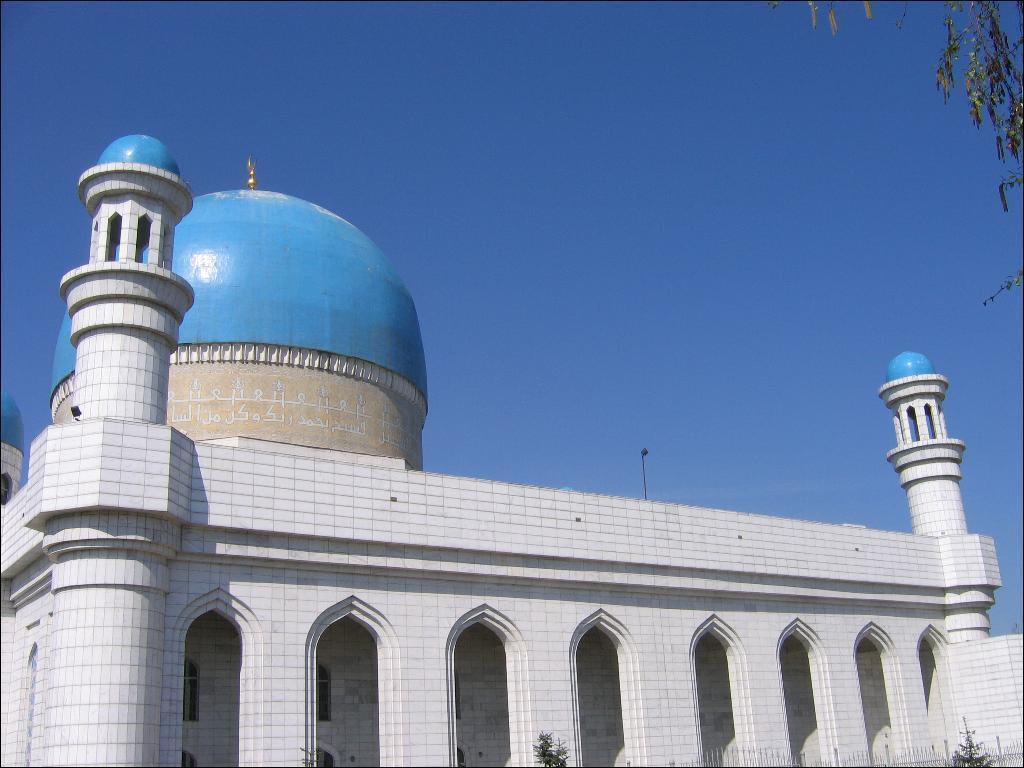Please provide a concise description of this image. In this image we can see a mosque, there is a tree and some plants, also we can see the sky. 